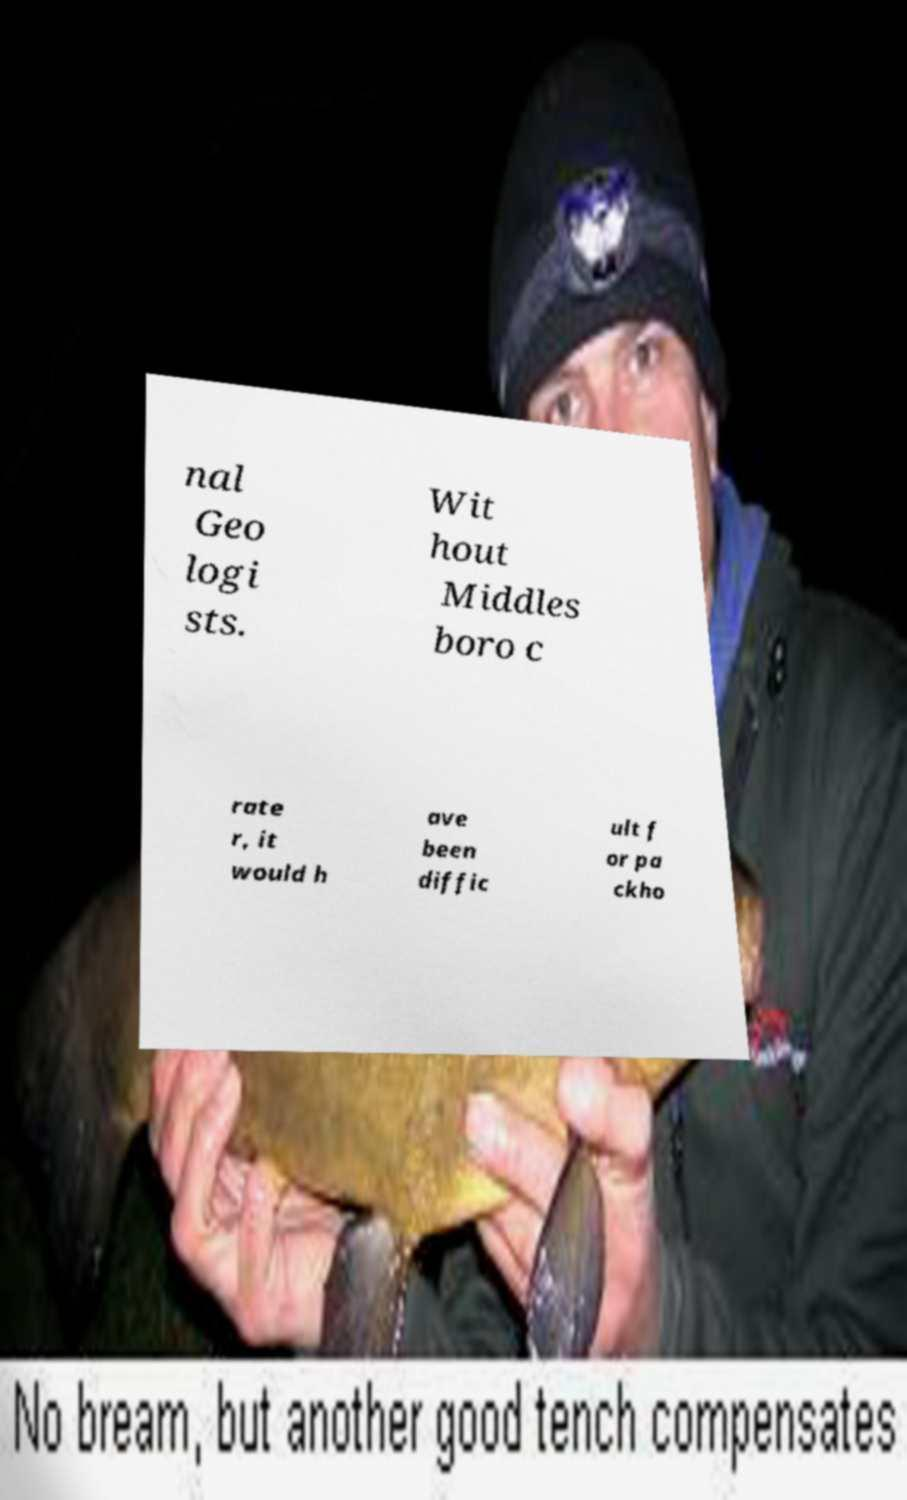For documentation purposes, I need the text within this image transcribed. Could you provide that? nal Geo logi sts. Wit hout Middles boro c rate r, it would h ave been diffic ult f or pa ckho 